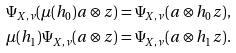Convert formula to latex. <formula><loc_0><loc_0><loc_500><loc_500>\Psi _ { X , \nu } ( \mu ( h _ { 0 } ) a \otimes z ) & = \Psi _ { X , \nu } ( a \otimes h _ { 0 } z ) , \\ \mu ( h _ { 1 } ) \Psi _ { X , \nu } ( a \otimes z ) & = \Psi _ { X , \nu } ( a \otimes h _ { 1 } z ) .</formula> 